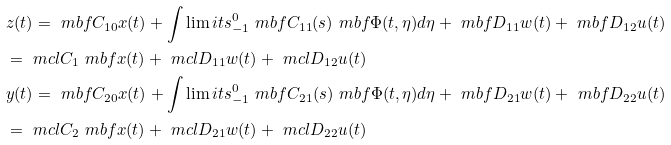Convert formula to latex. <formula><loc_0><loc_0><loc_500><loc_500>& z ( t ) = \ m b f C _ { 1 0 } x ( t ) + \int \lim i t s _ { - 1 } ^ { 0 } \ m b f C _ { 1 1 } ( s ) \ m b f \Phi ( t , \eta ) d \eta + \ m b f D _ { 1 1 } w ( t ) + \ m b f D _ { 1 2 } u ( t ) \\ & = \ m c l C _ { 1 } \ m b f x ( t ) + \ m c l D _ { 1 1 } w ( t ) + \ m c l D _ { 1 2 } u ( t ) \\ & y ( t ) = \ m b f C _ { 2 0 } x ( t ) + \int \lim i t s _ { - 1 } ^ { 0 } \ m b f C _ { 2 1 } ( s ) \ m b f \Phi ( t , \eta ) d \eta + \ m b f D _ { 2 1 } w ( t ) + \ m b f D _ { 2 2 } u ( t ) \\ & = \ m c l C _ { 2 } \ m b f x ( t ) + \ m c l D _ { 2 1 } w ( t ) + \ m c l D _ { 2 2 } u ( t )</formula> 